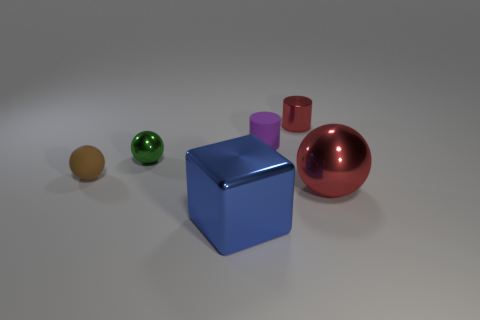Add 4 big blue cubes. How many objects exist? 10 Subtract all red cylinders. How many cylinders are left? 1 Subtract all small brown spheres. How many spheres are left? 2 Subtract all big red metal objects. Subtract all small red cylinders. How many objects are left? 4 Add 5 large blue metal blocks. How many large blue metal blocks are left? 6 Add 4 red matte things. How many red matte things exist? 4 Subtract 1 red cylinders. How many objects are left? 5 Subtract all cubes. How many objects are left? 5 Subtract 3 spheres. How many spheres are left? 0 Subtract all blue cylinders. Subtract all red blocks. How many cylinders are left? 2 